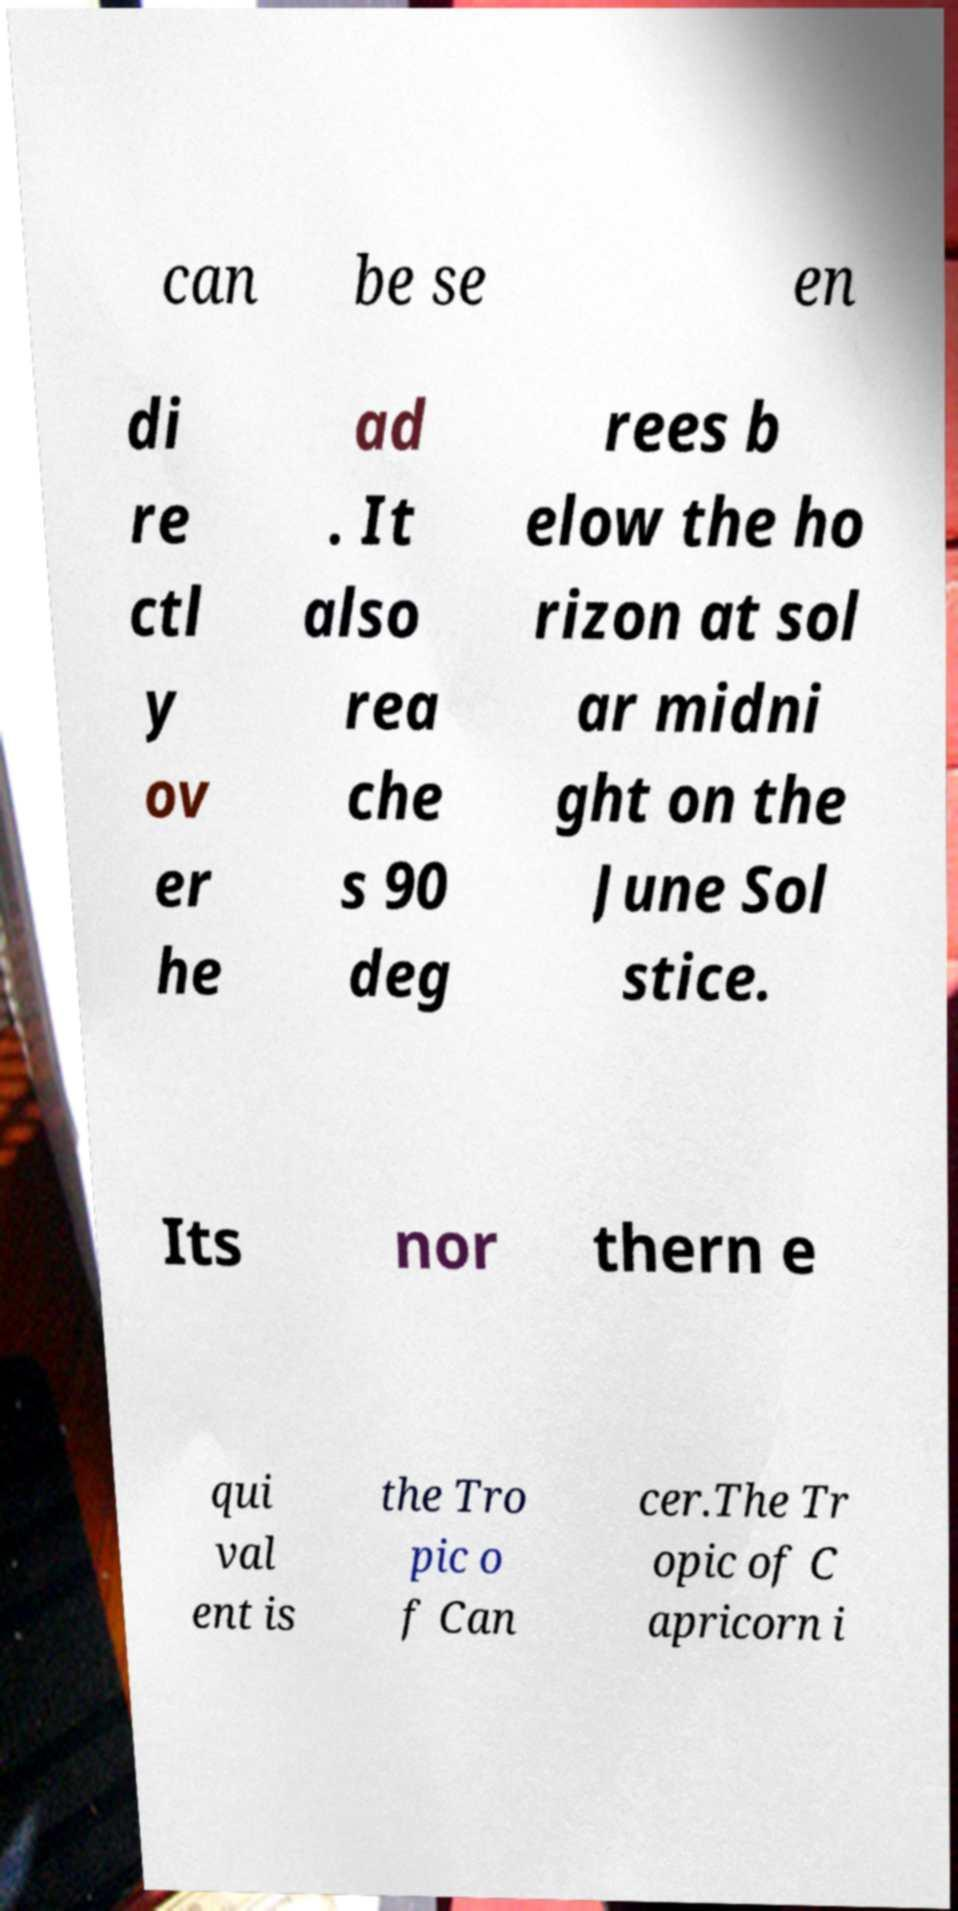Can you read and provide the text displayed in the image?This photo seems to have some interesting text. Can you extract and type it out for me? can be se en di re ctl y ov er he ad . It also rea che s 90 deg rees b elow the ho rizon at sol ar midni ght on the June Sol stice. Its nor thern e qui val ent is the Tro pic o f Can cer.The Tr opic of C apricorn i 